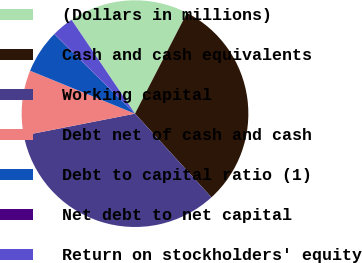<chart> <loc_0><loc_0><loc_500><loc_500><pie_chart><fcel>(Dollars in millions)<fcel>Cash and cash equivalents<fcel>Working capital<fcel>Debt net of cash and cash<fcel>Debt to capital ratio (1)<fcel>Net debt to net capital<fcel>Return on stockholders' equity<nl><fcel>17.05%<fcel>30.63%<fcel>33.7%<fcel>9.27%<fcel>6.19%<fcel>0.04%<fcel>3.12%<nl></chart> 